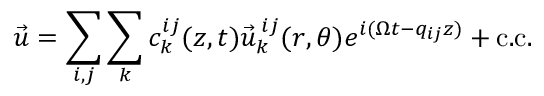Convert formula to latex. <formula><loc_0><loc_0><loc_500><loc_500>\vec { u } = \sum _ { i , j } \sum _ { k } c _ { k } ^ { i j } ( z , t ) \vec { u } _ { k } ^ { \, i j } ( r , \theta ) e ^ { i ( \Omega t - q _ { i j } z ) } + c . c .</formula> 